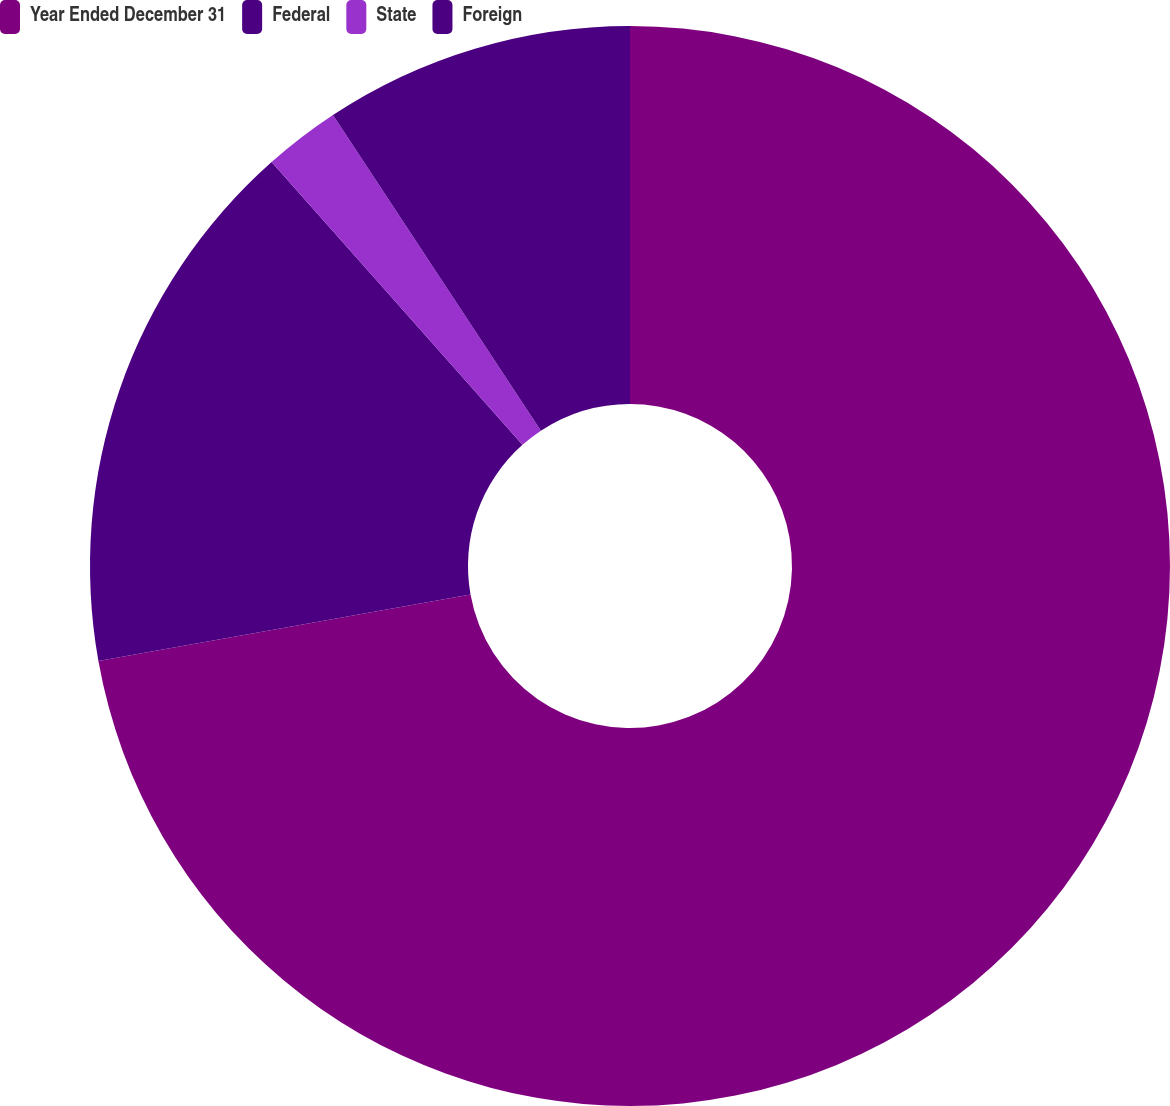Convert chart. <chart><loc_0><loc_0><loc_500><loc_500><pie_chart><fcel>Year Ended December 31<fcel>Federal<fcel>State<fcel>Foreign<nl><fcel>72.18%<fcel>16.26%<fcel>2.28%<fcel>9.27%<nl></chart> 